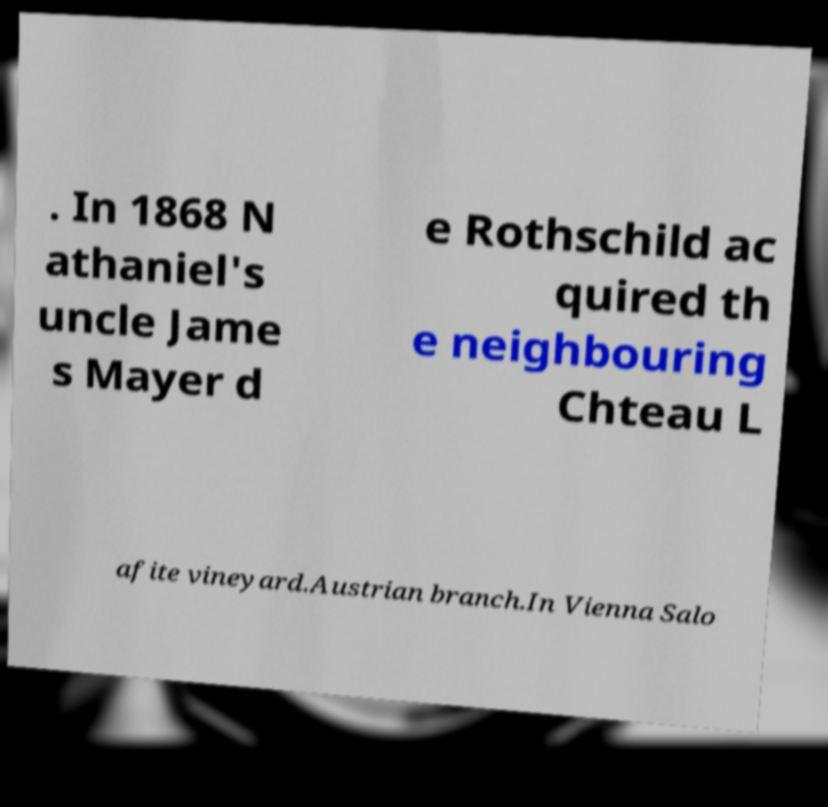Can you read and provide the text displayed in the image?This photo seems to have some interesting text. Can you extract and type it out for me? . In 1868 N athaniel's uncle Jame s Mayer d e Rothschild ac quired th e neighbouring Chteau L afite vineyard.Austrian branch.In Vienna Salo 